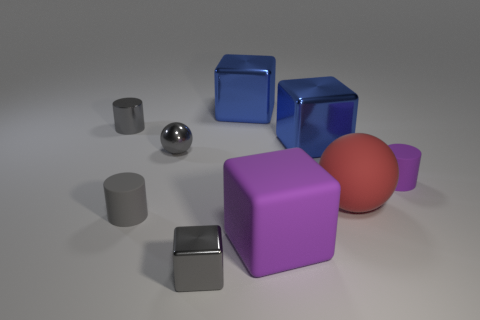Do the metallic cylinder and the rubber cylinder that is left of the rubber block have the same color?
Your answer should be very brief. Yes. There is a small rubber thing right of the small gray cube; how many gray metallic balls are to the right of it?
Make the answer very short. 0. There is a sphere that is the same color as the metal cylinder; what material is it?
Offer a terse response. Metal. How many other objects are there of the same color as the tiny metallic ball?
Offer a terse response. 3. What color is the tiny cylinder that is on the right side of the small gray metallic thing in front of the tiny gray ball?
Your response must be concise. Purple. Is there a small metallic cube of the same color as the small shiny sphere?
Provide a short and direct response. Yes. How many metal things are big red spheres or purple cylinders?
Provide a short and direct response. 0. Are there any other small cylinders that have the same material as the small purple cylinder?
Give a very brief answer. Yes. How many matte objects are both to the right of the gray sphere and on the left side of the tiny purple rubber object?
Offer a terse response. 2. Are there fewer tiny purple matte cylinders in front of the big ball than tiny gray metallic things to the left of the metal sphere?
Make the answer very short. Yes. 